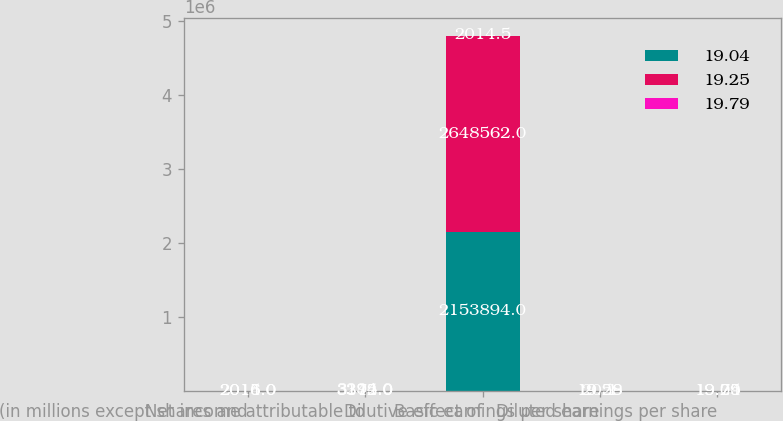Convert chart to OTSL. <chart><loc_0><loc_0><loc_500><loc_500><stacked_bar_chart><ecel><fcel>(in millions except shares and<fcel>Net income attributable to<fcel>Dilutive effect of<fcel>Basic earnings per share<fcel>Diluted earnings per share<nl><fcel>19.04<fcel>2016<fcel>3172<fcel>2.15389e+06<fcel>19.29<fcel>19.04<nl><fcel>19.25<fcel>2015<fcel>3345<fcel>2.64856e+06<fcel>20.1<fcel>19.79<nl><fcel>19.79<fcel>2014<fcel>3294<fcel>2014.5<fcel>19.58<fcel>19.25<nl></chart> 